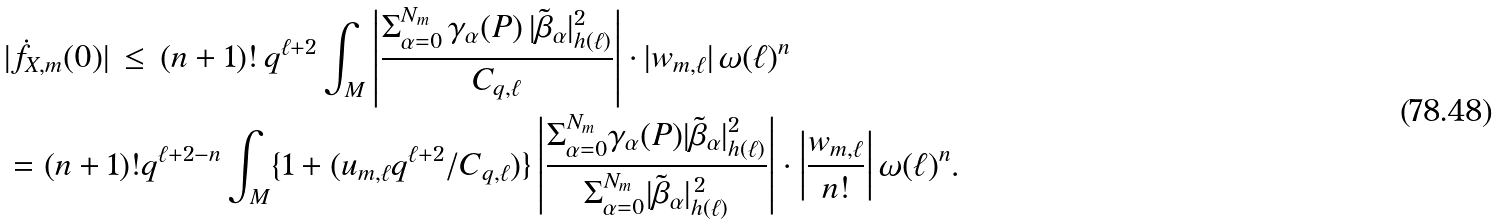<formula> <loc_0><loc_0><loc_500><loc_500>& | \dot { f } _ { X , m } ( 0 ) | \, \leq \, ( n + 1 ) ! \, q ^ { \ell + 2 } \int _ { M } \left | \frac { \Sigma _ { \alpha = 0 } ^ { N _ { m } } \, { \gamma } _ { \alpha } ( P ) \, | \tilde { \beta } _ { \alpha } | _ { h ( \ell ) } ^ { 2 } } { C _ { q , \ell } } \right | \cdot | w _ { m , \ell } | \, \omega ( \ell ) ^ { n } \\ & = ( n + 1 ) ! q ^ { \ell + 2 - n } \int _ { M } \{ 1 + ( u _ { m , \ell } q ^ { \ell + 2 } / C _ { q , \ell } ) \} \left | \frac { \Sigma _ { \alpha = 0 } ^ { N _ { m } } { \gamma } _ { \alpha } ( P ) | \tilde { \beta } _ { \alpha } | _ { h ( \ell ) } ^ { 2 } } { \Sigma _ { \alpha = 0 } ^ { N _ { m } } | \tilde { \beta } _ { \alpha } | _ { h ( \ell ) } ^ { \, 2 } } \right | \cdot \left | \frac { w _ { m , \ell } } { n ! } \right | \omega ( \ell ) ^ { n } .</formula> 